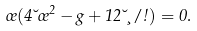Convert formula to latex. <formula><loc_0><loc_0><loc_500><loc_500>\sigma ( 4 \lambda \sigma ^ { 2 } - g + 1 2 \lambda \xi / \omega ) = 0 .</formula> 